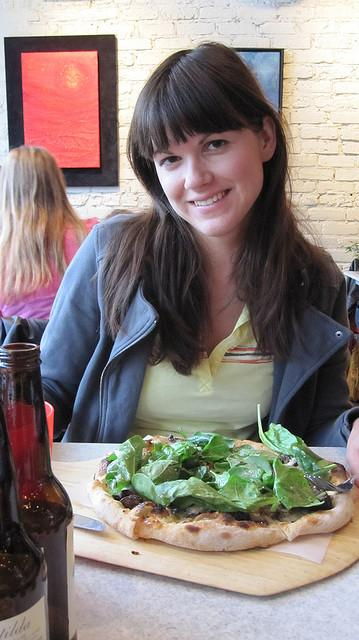What is adorning the pizza? spinach 